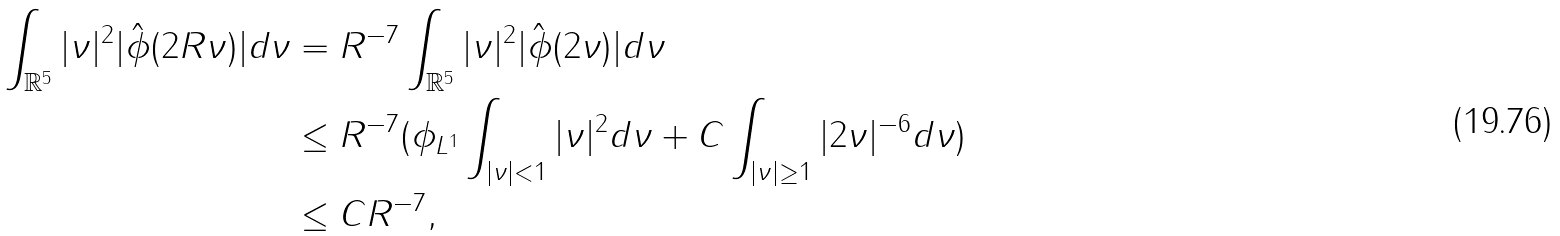<formula> <loc_0><loc_0><loc_500><loc_500>\int _ { \mathbb { R } ^ { 5 } } | \nu | ^ { 2 } | \hat { \phi } ( 2 R \nu ) | d \nu & = R ^ { - 7 } \int _ { \mathbb { R } ^ { 5 } } | \nu | ^ { 2 } | \hat { \phi } ( 2 \nu ) | d \nu \\ & \leq R ^ { - 7 } ( \| \phi \| _ { L ^ { 1 } } \int _ { | \nu | < 1 } | \nu | ^ { 2 } d \nu + C \int _ { | \nu | \geq 1 } | 2 \nu | ^ { - 6 } d \nu ) \\ & \leq C R ^ { - 7 } ,</formula> 